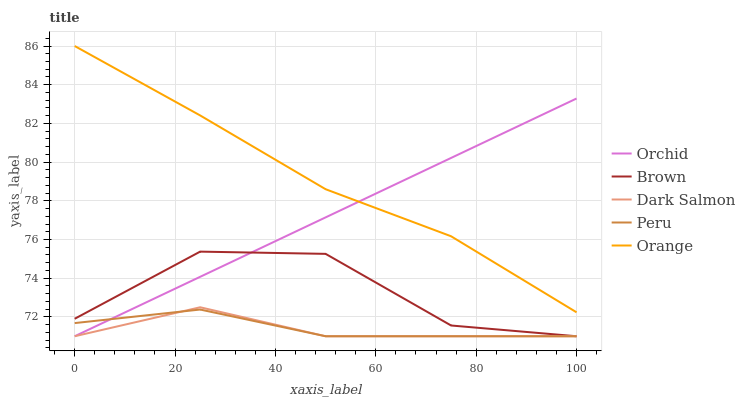Does Dark Salmon have the minimum area under the curve?
Answer yes or no. Yes. Does Orange have the maximum area under the curve?
Answer yes or no. Yes. Does Brown have the minimum area under the curve?
Answer yes or no. No. Does Brown have the maximum area under the curve?
Answer yes or no. No. Is Orchid the smoothest?
Answer yes or no. Yes. Is Brown the roughest?
Answer yes or no. Yes. Is Dark Salmon the smoothest?
Answer yes or no. No. Is Dark Salmon the roughest?
Answer yes or no. No. Does Brown have the lowest value?
Answer yes or no. Yes. Does Orange have the highest value?
Answer yes or no. Yes. Does Brown have the highest value?
Answer yes or no. No. Is Dark Salmon less than Orange?
Answer yes or no. Yes. Is Orange greater than Dark Salmon?
Answer yes or no. Yes. Does Dark Salmon intersect Peru?
Answer yes or no. Yes. Is Dark Salmon less than Peru?
Answer yes or no. No. Is Dark Salmon greater than Peru?
Answer yes or no. No. Does Dark Salmon intersect Orange?
Answer yes or no. No. 